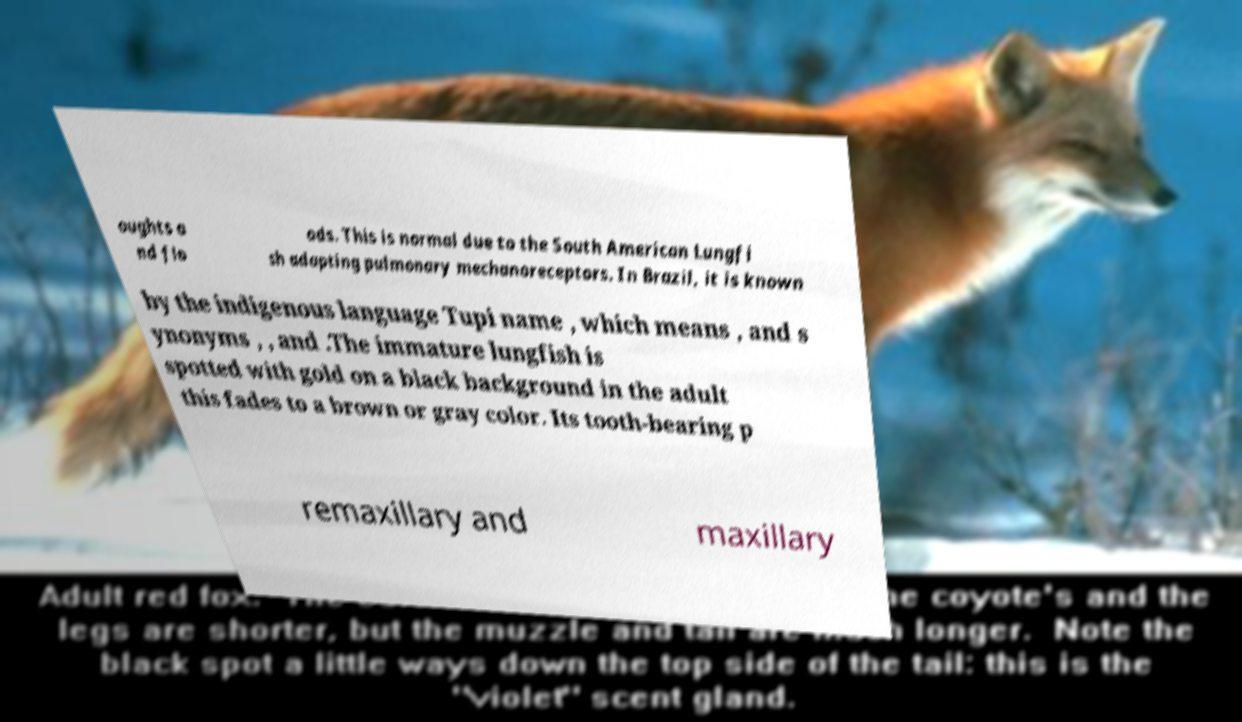What messages or text are displayed in this image? I need them in a readable, typed format. oughts a nd flo ods. This is normal due to the South American Lungfi sh adapting pulmonary mechanoreceptors. In Brazil, it is known by the indigenous language Tupi name , which means , and s ynonyms , , and .The immature lungfish is spotted with gold on a black background in the adult this fades to a brown or gray color. Its tooth-bearing p remaxillary and maxillary 